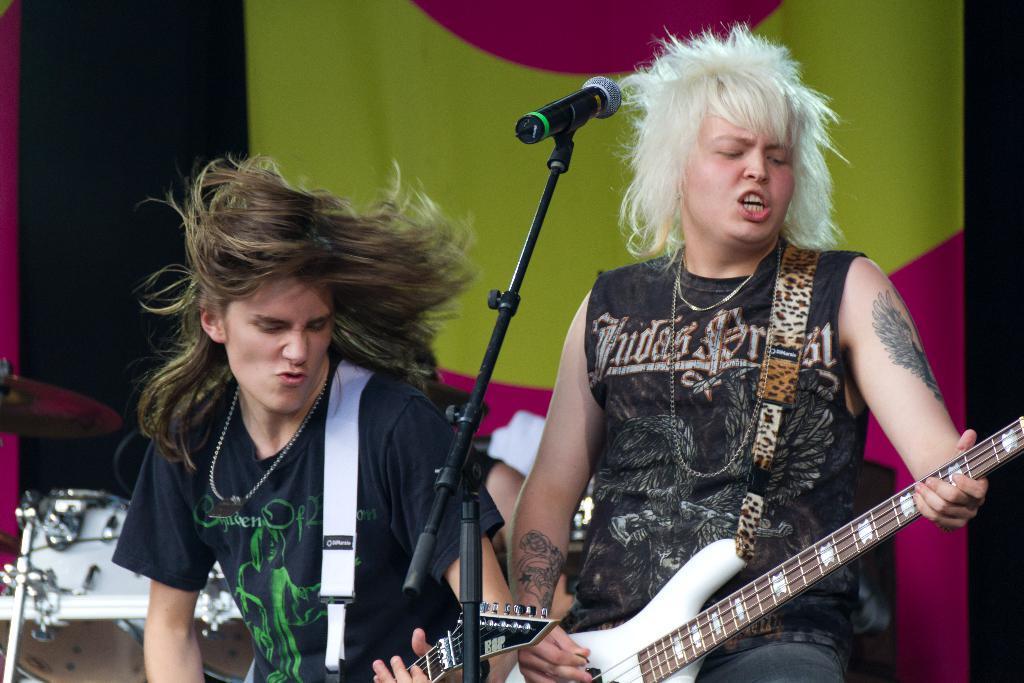In one or two sentences, can you explain what this image depicts? In this image we can see three people playing musical instruments on the stage and there is a mic in front of them. In the background, we can see an object which looks like a banner. 